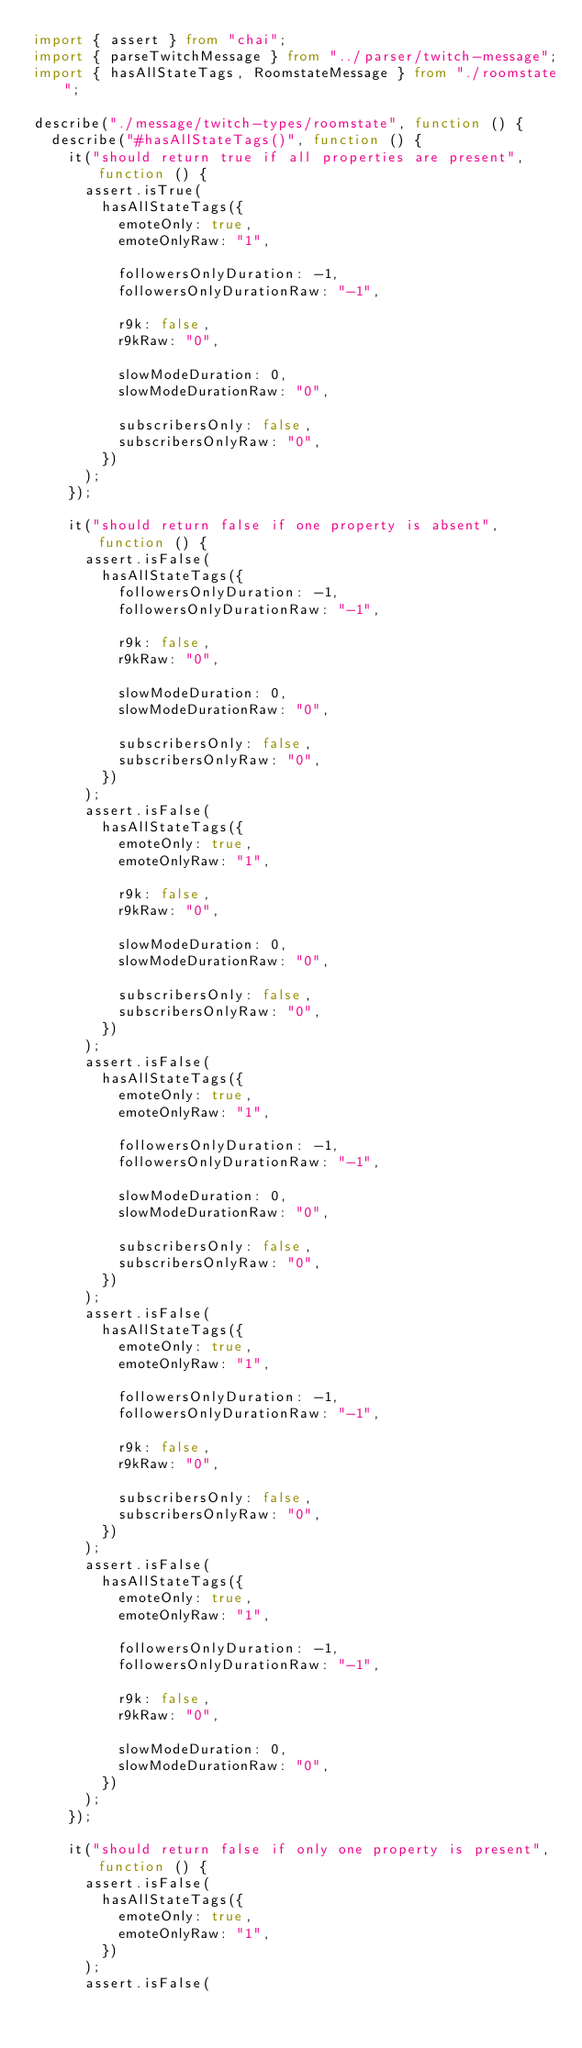<code> <loc_0><loc_0><loc_500><loc_500><_TypeScript_>import { assert } from "chai";
import { parseTwitchMessage } from "../parser/twitch-message";
import { hasAllStateTags, RoomstateMessage } from "./roomstate";

describe("./message/twitch-types/roomstate", function () {
  describe("#hasAllStateTags()", function () {
    it("should return true if all properties are present", function () {
      assert.isTrue(
        hasAllStateTags({
          emoteOnly: true,
          emoteOnlyRaw: "1",

          followersOnlyDuration: -1,
          followersOnlyDurationRaw: "-1",

          r9k: false,
          r9kRaw: "0",

          slowModeDuration: 0,
          slowModeDurationRaw: "0",

          subscribersOnly: false,
          subscribersOnlyRaw: "0",
        })
      );
    });

    it("should return false if one property is absent", function () {
      assert.isFalse(
        hasAllStateTags({
          followersOnlyDuration: -1,
          followersOnlyDurationRaw: "-1",

          r9k: false,
          r9kRaw: "0",

          slowModeDuration: 0,
          slowModeDurationRaw: "0",

          subscribersOnly: false,
          subscribersOnlyRaw: "0",
        })
      );
      assert.isFalse(
        hasAllStateTags({
          emoteOnly: true,
          emoteOnlyRaw: "1",

          r9k: false,
          r9kRaw: "0",

          slowModeDuration: 0,
          slowModeDurationRaw: "0",

          subscribersOnly: false,
          subscribersOnlyRaw: "0",
        })
      );
      assert.isFalse(
        hasAllStateTags({
          emoteOnly: true,
          emoteOnlyRaw: "1",

          followersOnlyDuration: -1,
          followersOnlyDurationRaw: "-1",

          slowModeDuration: 0,
          slowModeDurationRaw: "0",

          subscribersOnly: false,
          subscribersOnlyRaw: "0",
        })
      );
      assert.isFalse(
        hasAllStateTags({
          emoteOnly: true,
          emoteOnlyRaw: "1",

          followersOnlyDuration: -1,
          followersOnlyDurationRaw: "-1",

          r9k: false,
          r9kRaw: "0",

          subscribersOnly: false,
          subscribersOnlyRaw: "0",
        })
      );
      assert.isFalse(
        hasAllStateTags({
          emoteOnly: true,
          emoteOnlyRaw: "1",

          followersOnlyDuration: -1,
          followersOnlyDurationRaw: "-1",

          r9k: false,
          r9kRaw: "0",

          slowModeDuration: 0,
          slowModeDurationRaw: "0",
        })
      );
    });

    it("should return false if only one property is present", function () {
      assert.isFalse(
        hasAllStateTags({
          emoteOnly: true,
          emoteOnlyRaw: "1",
        })
      );
      assert.isFalse(</code> 